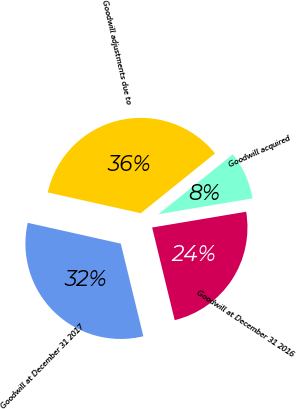<chart> <loc_0><loc_0><loc_500><loc_500><pie_chart><fcel>Goodwill at December 31 2016<fcel>Goodwill acquired<fcel>Goodwill adjustments due to<fcel>Goodwill at December 31 2017<nl><fcel>23.84%<fcel>8.14%<fcel>35.71%<fcel>32.31%<nl></chart> 